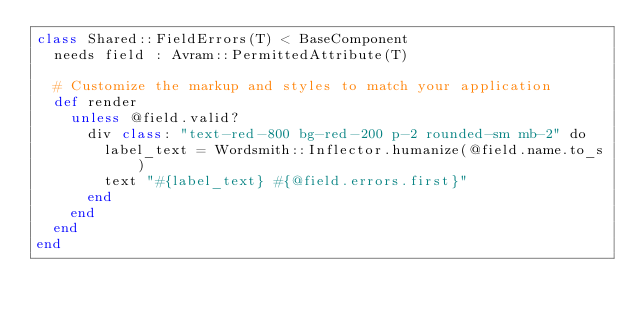<code> <loc_0><loc_0><loc_500><loc_500><_Crystal_>class Shared::FieldErrors(T) < BaseComponent
  needs field : Avram::PermittedAttribute(T)

  # Customize the markup and styles to match your application
  def render
    unless @field.valid?
      div class: "text-red-800 bg-red-200 p-2 rounded-sm mb-2" do
        label_text = Wordsmith::Inflector.humanize(@field.name.to_s)
        text "#{label_text} #{@field.errors.first}"
      end
    end
  end
end
</code> 